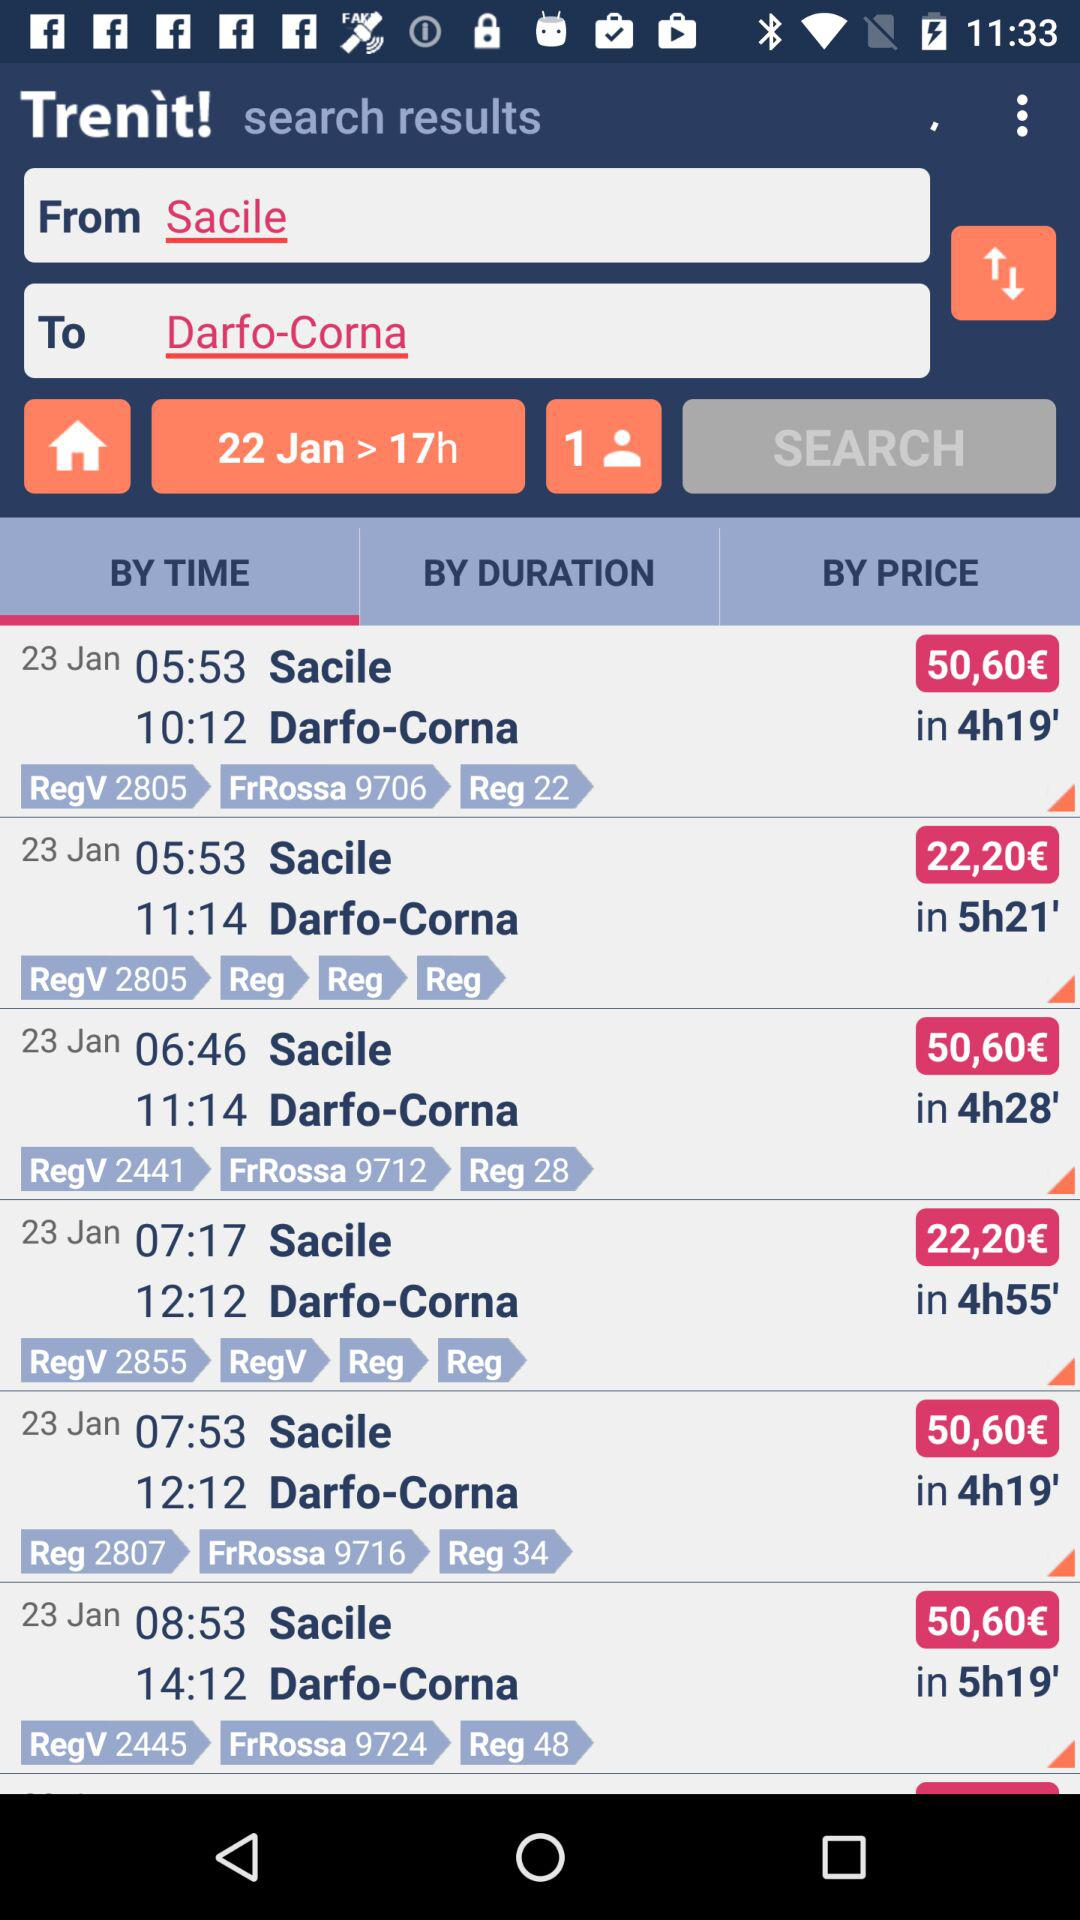How much is the fare on January 23 from 7:17 to 12:12? The fare is 22,20€. 